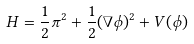Convert formula to latex. <formula><loc_0><loc_0><loc_500><loc_500>H = \frac { 1 } { 2 } \pi ^ { 2 } + \frac { 1 } { 2 } ( \nabla \phi ) ^ { 2 } + V ( \phi )</formula> 